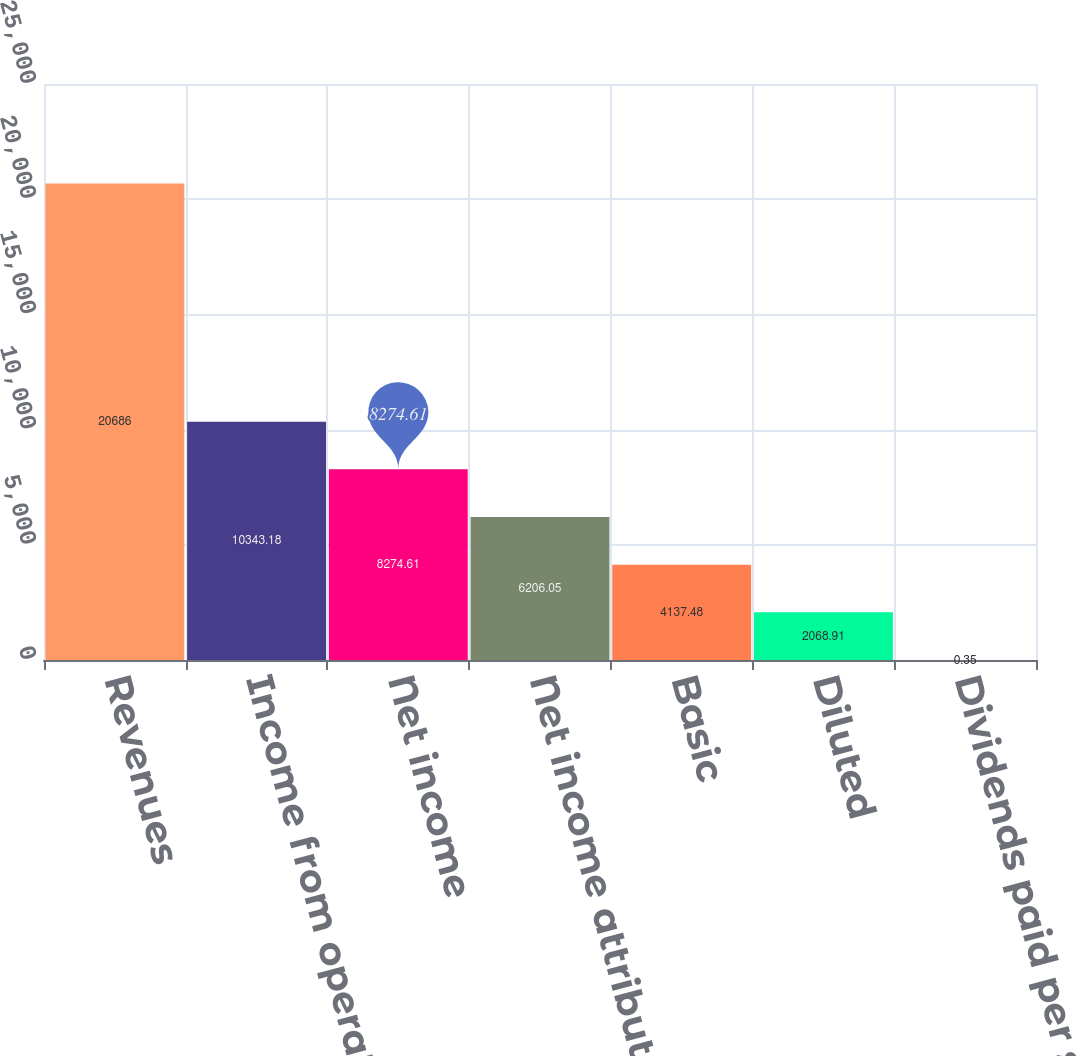Convert chart to OTSL. <chart><loc_0><loc_0><loc_500><loc_500><bar_chart><fcel>Revenues<fcel>Income from operations<fcel>Net income<fcel>Net income attributable to MPC<fcel>Basic<fcel>Diluted<fcel>Dividends paid per share<nl><fcel>20686<fcel>10343.2<fcel>8274.61<fcel>6206.05<fcel>4137.48<fcel>2068.91<fcel>0.35<nl></chart> 